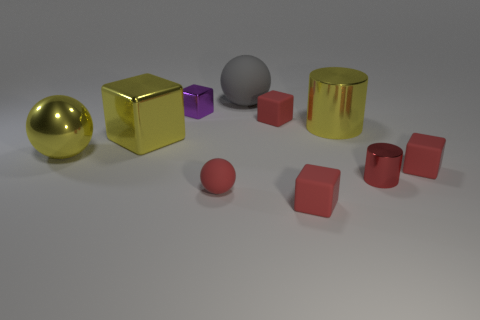Subtract all large yellow metallic cubes. How many cubes are left? 4 Subtract all cylinders. How many objects are left? 8 Subtract 0 purple balls. How many objects are left? 10 Subtract 1 spheres. How many spheres are left? 2 Subtract all purple cylinders. Subtract all red blocks. How many cylinders are left? 2 Subtract all cyan cylinders. How many yellow cubes are left? 1 Subtract all metallic cubes. Subtract all small red spheres. How many objects are left? 7 Add 5 small metal cylinders. How many small metal cylinders are left? 6 Add 1 tiny blue metal cylinders. How many tiny blue metal cylinders exist? 1 Subtract all red cylinders. How many cylinders are left? 1 